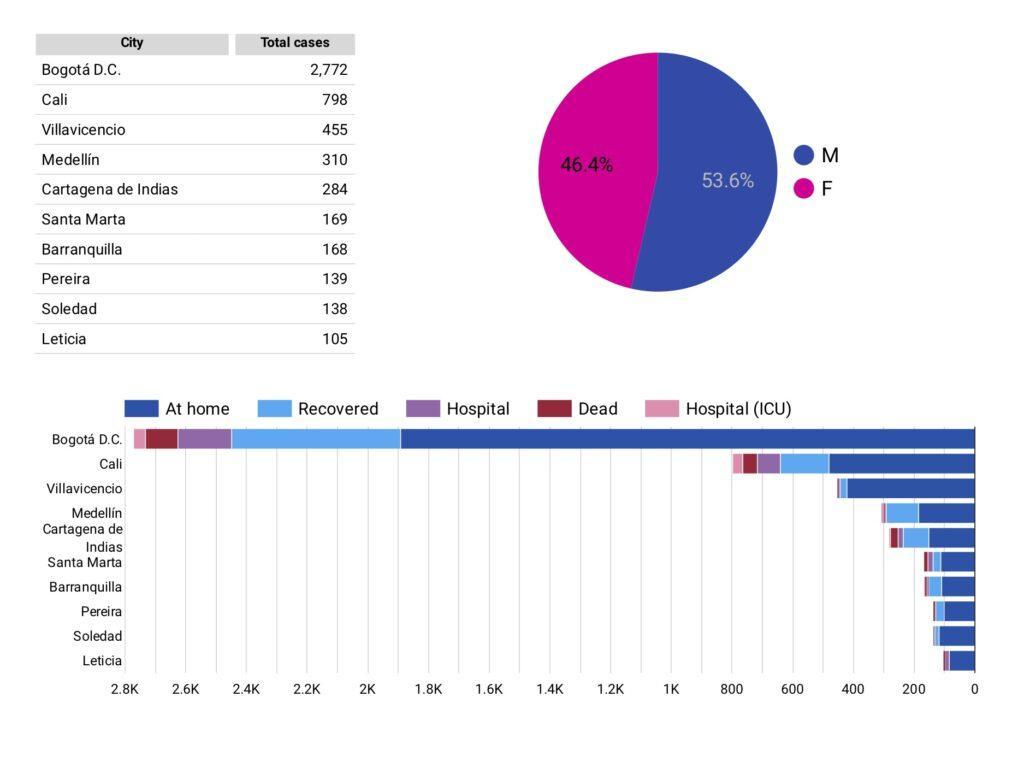What is the percentage of female cases?
Answer the question with a short phrase. 46.4 % Which city has a second least number of cases? Soledad Which two cities have 'at-home' cases between 400 and 600? Cali, Villavicencio By how much is the number of total cases in Santa Maria higher than in Pereira? 30 By how much is the number of Total cases in Pereira higher than Soledad? 1 How many cities have less than 200 total cases? 5 By how much is the number of total cases in Barranquilla higher than Soledad? 30 Which colour is used to represent hospital (ICU) cases - red, blue, pink or green? Pink What is the percentage of male cases? 53.6% Which regions have  total cases between 300 and 500? Medellin, Villavicencio How many cities have more than 400 total cases? 3 